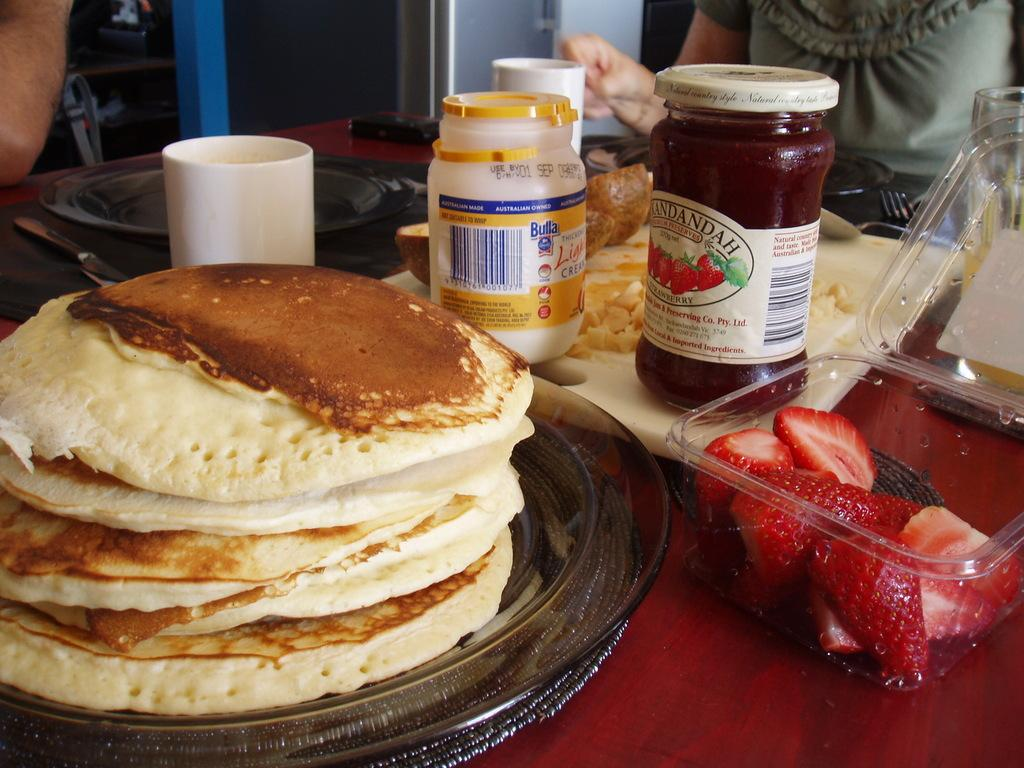What type of fruit is associated with the boxes in the image? The strawberry boxes in the image are associated with strawberries. What type of food is visible on the table in the image? There are pancakes, peanut butter, and sauce visible on the table in the image. What type of container is present in the image? There is a cup in the image. What is the setting of the image? There are people sitting behind a table in the image. What type of headwear is being worn by the strawberries in the image? There are no strawberries wearing headwear in the image; the strawberries are in boxes. What type of cream is being used to make the sauce in the image? There is no cream mentioned in the sauce in the image; only the sauce is visible. 